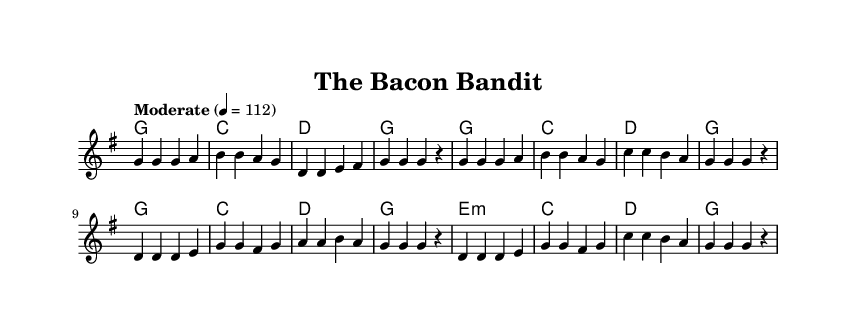What is the key signature of this music? The key signature is indicated at the beginning of the sheet music where there are no sharps or flats, meaning it is in G major.
Answer: G major What is the time signature of this song? The time signature is found at the start of the staff and shows four beats per measure, which is indicated by "4/4".
Answer: 4/4 What is the tempo marking for the song? The tempo marking is mentioned at the beginning of the music, stating "Moderate" with a tempo of quarter note equals 112.
Answer: Moderate How many measures are in the verse section? The verse consists of two repeated sections, and each has four measures, resulting in a total of eight measures.
Answer: 8 What is the main theme of the lyrics? The lyrics describe a character known as the "Bacon Bandit," focusing on his humorous habits and quirks related to food.
Answer: A character's humorous food habits How does the harmony progress in the chorus? The harmony in the chorus progresses sequentially through G, C, D, and G before moving to E minor and back to D and G, creating a simple yet effective structure.
Answer: G, C, D, G, E minor, C, D, G What instrument is primarily displayed in this sheet music? The sheet music shows a single staff, which typically indicates that a melody or vocal line is primarily intended for an instrument, often guitar or piano.
Answer: Staff for melodic instrument 